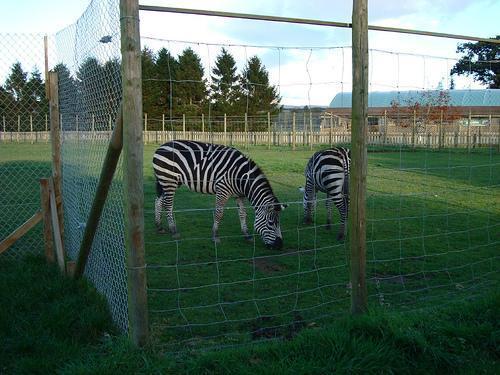How many zebras can be seen?
Give a very brief answer. 2. 